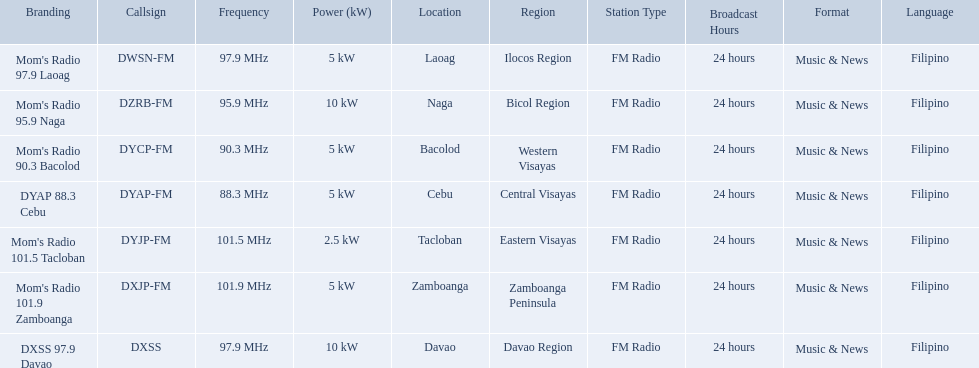What is the power capacity in kw for each team? 5 kW, 10 kW, 5 kW, 5 kW, 2.5 kW, 5 kW, 10 kW. Which is the lowest? 2.5 kW. What station has this amount of power? Mom's Radio 101.5 Tacloban. Which stations use less than 10kw of power? Mom's Radio 97.9 Laoag, Mom's Radio 90.3 Bacolod, DYAP 88.3 Cebu, Mom's Radio 101.5 Tacloban, Mom's Radio 101.9 Zamboanga. Do any stations use less than 5kw of power? if so, which ones? Mom's Radio 101.5 Tacloban. Could you parse the entire table? {'header': ['Branding', 'Callsign', 'Frequency', 'Power (kW)', 'Location', 'Region', 'Station Type', 'Broadcast Hours', 'Format', 'Language'], 'rows': [["Mom's Radio 97.9 Laoag", 'DWSN-FM', '97.9\xa0MHz', '5\xa0kW', 'Laoag', 'Ilocos Region', 'FM Radio', '24 hours', 'Music & News', 'Filipino'], ["Mom's Radio 95.9 Naga", 'DZRB-FM', '95.9\xa0MHz', '10\xa0kW', 'Naga', 'Bicol Region', 'FM Radio', '24 hours', 'Music & News', 'Filipino'], ["Mom's Radio 90.3 Bacolod", 'DYCP-FM', '90.3\xa0MHz', '5\xa0kW', 'Bacolod', 'Western Visayas', 'FM Radio', '24 hours', 'Music & News', 'Filipino'], ['DYAP 88.3 Cebu', 'DYAP-FM', '88.3\xa0MHz', '5\xa0kW', 'Cebu', 'Central Visayas', 'FM Radio', '24 hours', 'Music & News', 'Filipino'], ["Mom's Radio 101.5 Tacloban", 'DYJP-FM', '101.5\xa0MHz', '2.5\xa0kW', 'Tacloban', 'Eastern Visayas', 'FM Radio', '24 hours', 'Music & News', 'Filipino'], ["Mom's Radio 101.9 Zamboanga", 'DXJP-FM', '101.9\xa0MHz', '5\xa0kW', 'Zamboanga', 'Zamboanga Peninsula', 'FM Radio', '24 hours', 'Music & News', 'Filipino'], ['DXSS 97.9 Davao', 'DXSS', '97.9\xa0MHz', '10\xa0kW', 'Davao', 'Davao Region', 'FM Radio', '24 hours', 'Music & News', 'Filipino']]} Which stations broadcast in dyap-fm? Mom's Radio 97.9 Laoag, Mom's Radio 95.9 Naga, Mom's Radio 90.3 Bacolod, DYAP 88.3 Cebu, Mom's Radio 101.5 Tacloban, Mom's Radio 101.9 Zamboanga, DXSS 97.9 Davao. Of those stations which broadcast in dyap-fm, which stations broadcast with 5kw of power or under? Mom's Radio 97.9 Laoag, Mom's Radio 90.3 Bacolod, DYAP 88.3 Cebu, Mom's Radio 101.5 Tacloban, Mom's Radio 101.9 Zamboanga. Of those stations that broadcast with 5kw of power or under, which broadcasts with the least power? Mom's Radio 101.5 Tacloban. What are all of the frequencies? 97.9 MHz, 95.9 MHz, 90.3 MHz, 88.3 MHz, 101.5 MHz, 101.9 MHz, 97.9 MHz. Which of these frequencies is the lowest? 88.3 MHz. Which branding does this frequency belong to? DYAP 88.3 Cebu. 